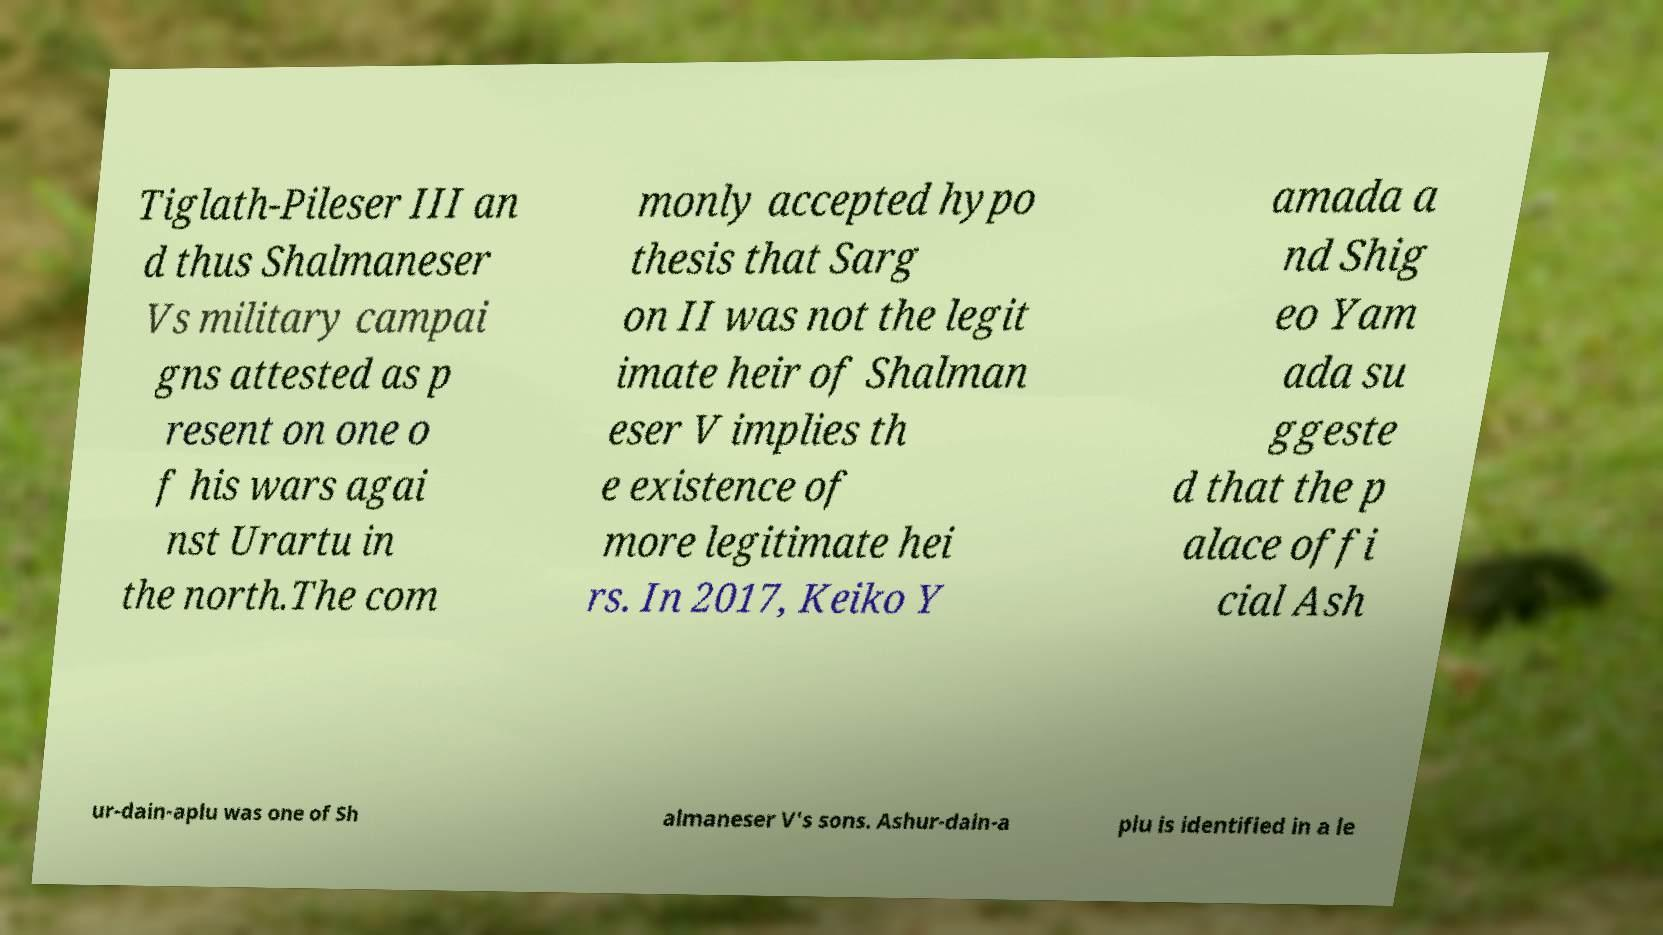What messages or text are displayed in this image? I need them in a readable, typed format. Tiglath-Pileser III an d thus Shalmaneser Vs military campai gns attested as p resent on one o f his wars agai nst Urartu in the north.The com monly accepted hypo thesis that Sarg on II was not the legit imate heir of Shalman eser V implies th e existence of more legitimate hei rs. In 2017, Keiko Y amada a nd Shig eo Yam ada su ggeste d that the p alace offi cial Ash ur-dain-aplu was one of Sh almaneser V's sons. Ashur-dain-a plu is identified in a le 